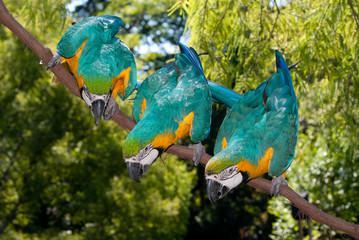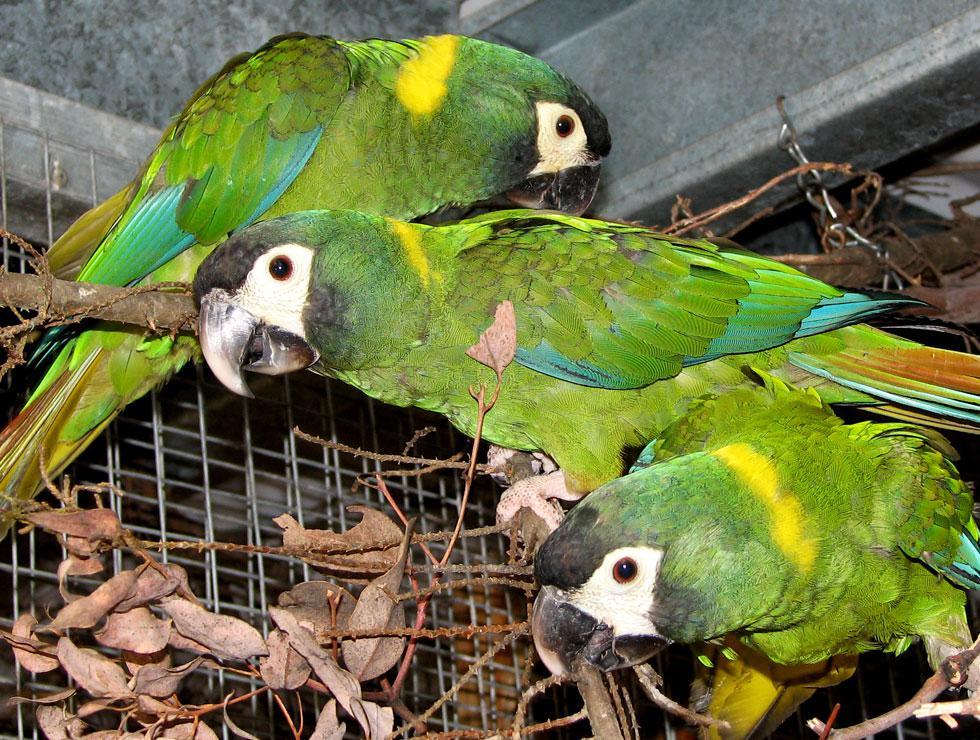The first image is the image on the left, the second image is the image on the right. Considering the images on both sides, is "In one image there are four blue birds perched on a branch." valid? Answer yes or no. Yes. The first image is the image on the left, the second image is the image on the right. Considering the images on both sides, is "The right image features a blue-and-yellow parrot only, and the left image includes at least one red-headed parrot." valid? Answer yes or no. No. 